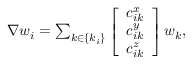Convert formula to latex. <formula><loc_0><loc_0><loc_500><loc_500>\begin{array} { r } { { \nabla } w _ { i } = \sum _ { k \in \{ k _ { i } \} } \left [ \begin{array} { c } { c _ { i k } ^ { x } } \\ { c _ { i k } ^ { y } } \\ { c _ { i k } ^ { z } } \end{array} \right ] w _ { k } , } \end{array}</formula> 